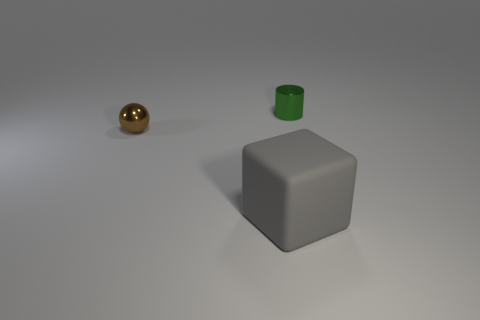There is a small object right of the gray thing; is there a brown sphere that is in front of it?
Your answer should be very brief. Yes. There is a thing that is both behind the rubber object and on the right side of the brown metallic ball; what material is it made of?
Ensure brevity in your answer.  Metal. There is a tiny brown object that is made of the same material as the tiny green object; what shape is it?
Make the answer very short. Sphere. Is there anything else that is the same shape as the tiny brown shiny thing?
Keep it short and to the point. No. Are the tiny thing to the left of the large gray rubber object and the big gray thing made of the same material?
Your answer should be very brief. No. There is a small thing to the left of the cylinder; what material is it?
Your response must be concise. Metal. There is a shiny thing behind the object that is left of the big gray cube; what is its size?
Your answer should be very brief. Small. How many gray matte things are the same size as the brown shiny object?
Provide a succinct answer. 0. Do the tiny shiny object in front of the tiny green cylinder and the metal thing on the right side of the big rubber object have the same color?
Offer a very short reply. No. Are there any tiny metal things behind the tiny brown shiny object?
Give a very brief answer. Yes. 